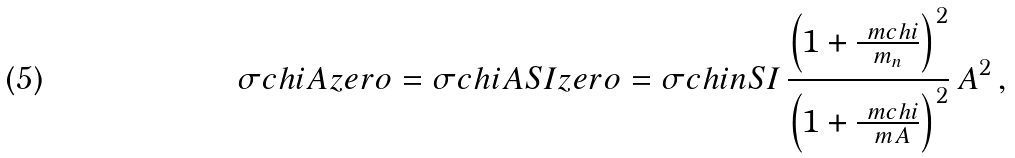<formula> <loc_0><loc_0><loc_500><loc_500>\sigma c h i A z e r o = \sigma c h i A S I z e r o = \sigma c h i n S I \, \frac { \left ( 1 + \frac { \ m c h i } { m _ { n } } \right ) ^ { 2 } } { \left ( 1 + \frac { \ m c h i } { \ m A } \right ) ^ { 2 } } \, A ^ { 2 } \, ,</formula> 